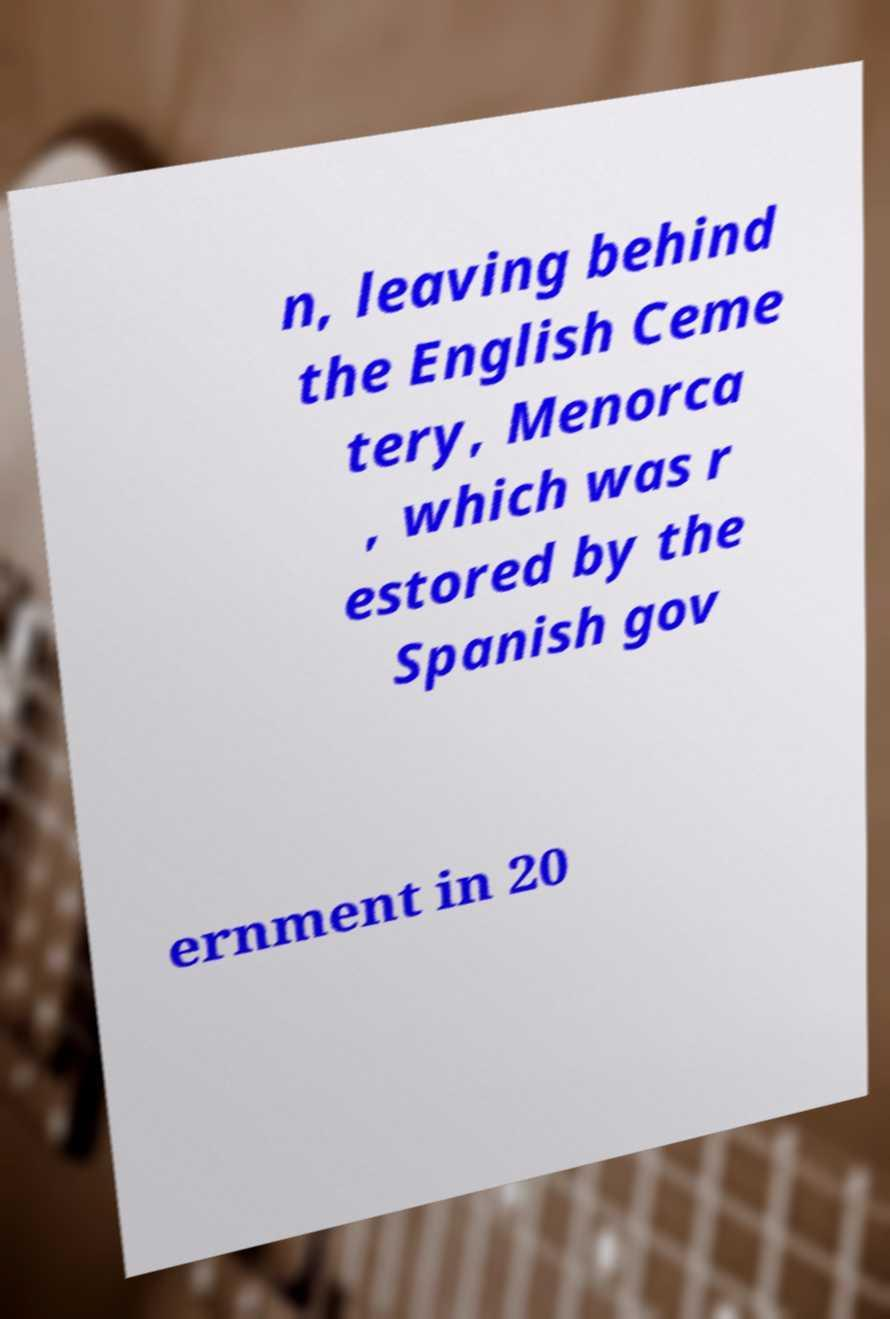Please identify and transcribe the text found in this image. n, leaving behind the English Ceme tery, Menorca , which was r estored by the Spanish gov ernment in 20 